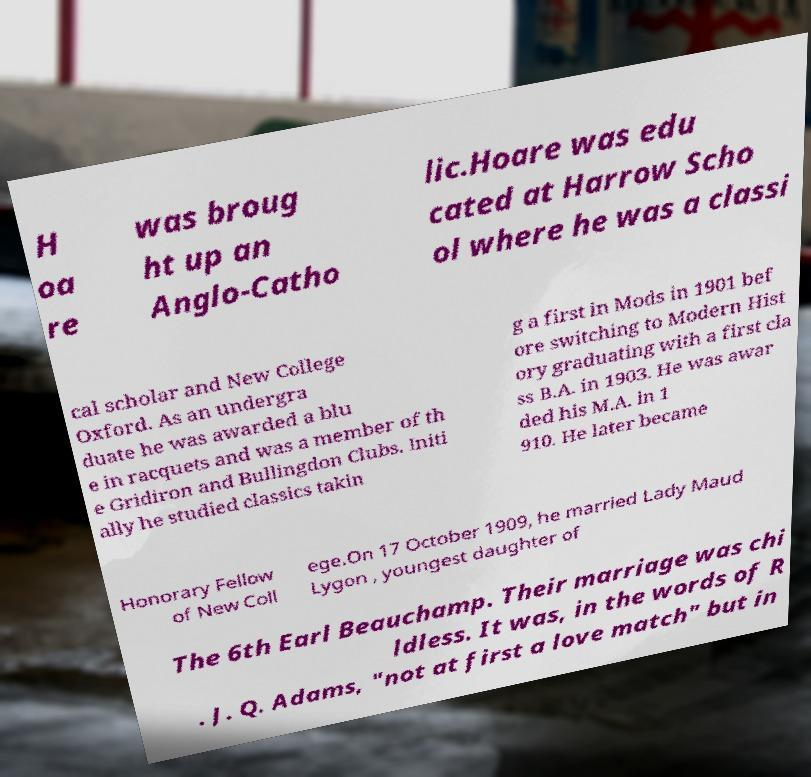For documentation purposes, I need the text within this image transcribed. Could you provide that? H oa re was broug ht up an Anglo-Catho lic.Hoare was edu cated at Harrow Scho ol where he was a classi cal scholar and New College Oxford. As an undergra duate he was awarded a blu e in racquets and was a member of th e Gridiron and Bullingdon Clubs. Initi ally he studied classics takin g a first in Mods in 1901 bef ore switching to Modern Hist ory graduating with a first cla ss B.A. in 1903. He was awar ded his M.A. in 1 910. He later became Honorary Fellow of New Coll ege.On 17 October 1909, he married Lady Maud Lygon , youngest daughter of The 6th Earl Beauchamp. Their marriage was chi ldless. It was, in the words of R . J. Q. Adams, "not at first a love match" but in 